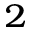Convert formula to latex. <formula><loc_0><loc_0><loc_500><loc_500>^ { 2 }</formula> 